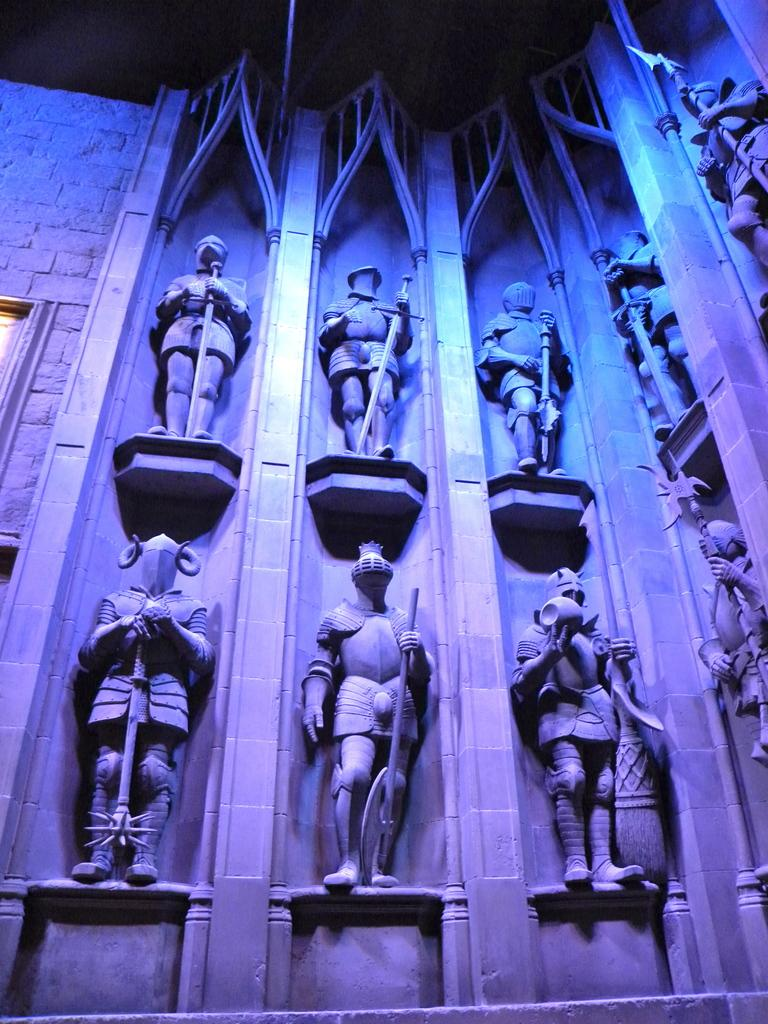What type of objects can be seen in the image? There are statues in the image. What kind of structure is present in the image? There is a stone wall in the image. What colors of light can be observed in the image? Blue and pink color lights are visible in the image. How many zebras can be seen running in a specific direction in the image? There are no zebras present in the image, so it is not possible to answer that question. 